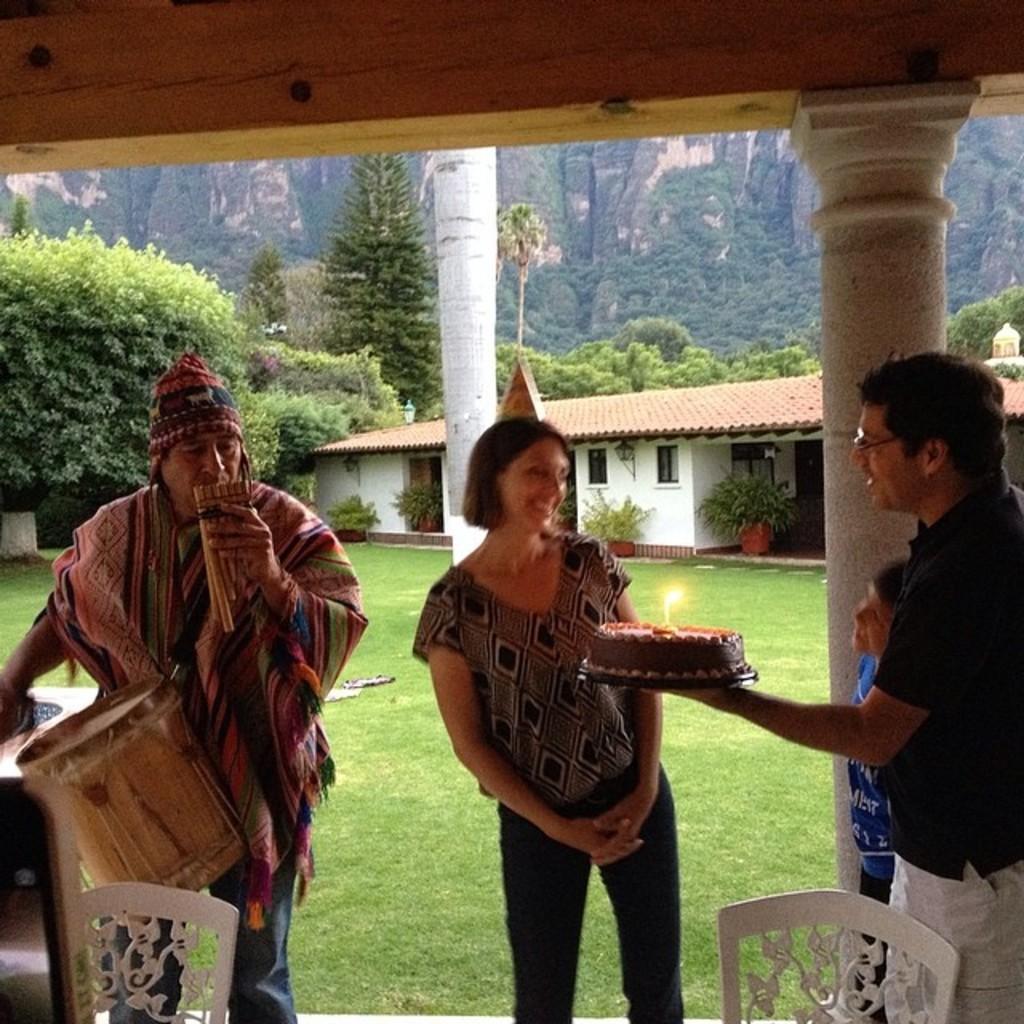Could you give a brief overview of what you see in this image? This is the picture outside of the house and there's grass on the floor and there is a hill on the background and there is a plant and trees on the ground ,on the front left side there is a person wearing a red color scarf holding a musical instrument ,in front of him there is a chair ,on the right corner a person wearing a black color t-shirt beside him a baby boy is standing ,and a person holding a cake ,in front of the cake there is a woman standing and she is smiling and there is a candle on the cake and there are from flower pot kept in front of the the house 